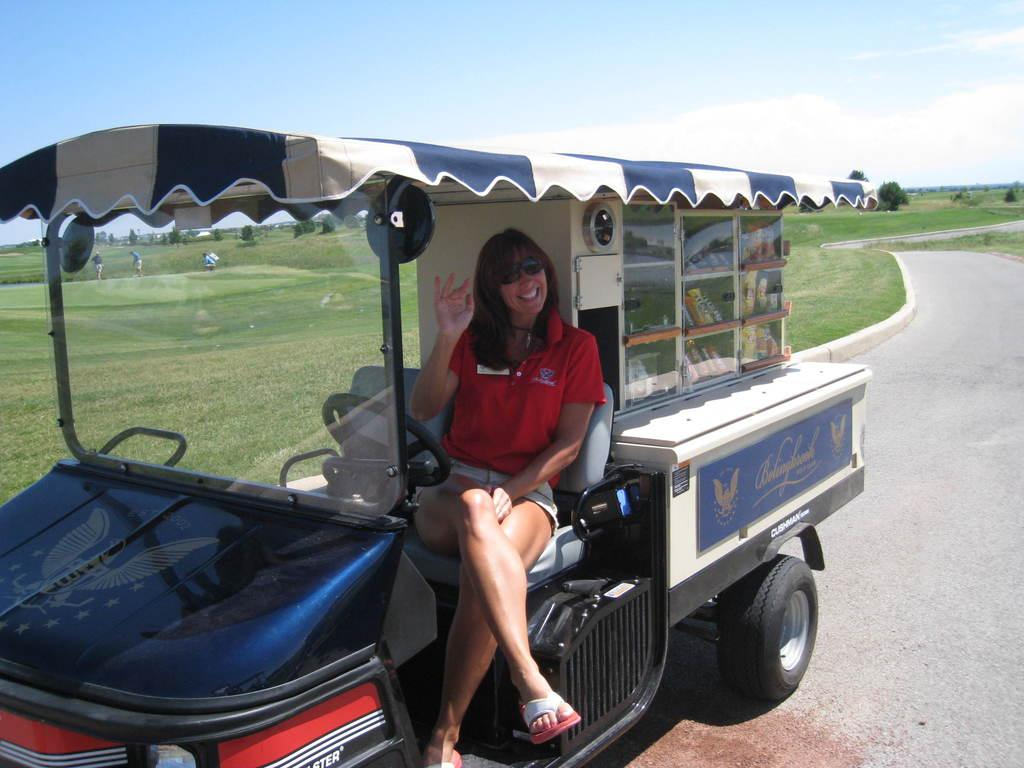What is the girl doing in the image? The girl is sitting in a truck. What is the purpose of the truck in the image? The truck is carrying some stuff. What can be seen in the background near the girl? There is grass beside the girl. What type of agreement was reached between the girl and the truck in the image? There is no indication of any agreement between the girl and the truck in the image. The girl is simply sitting in the truck, and the truck is carrying some stuff. 